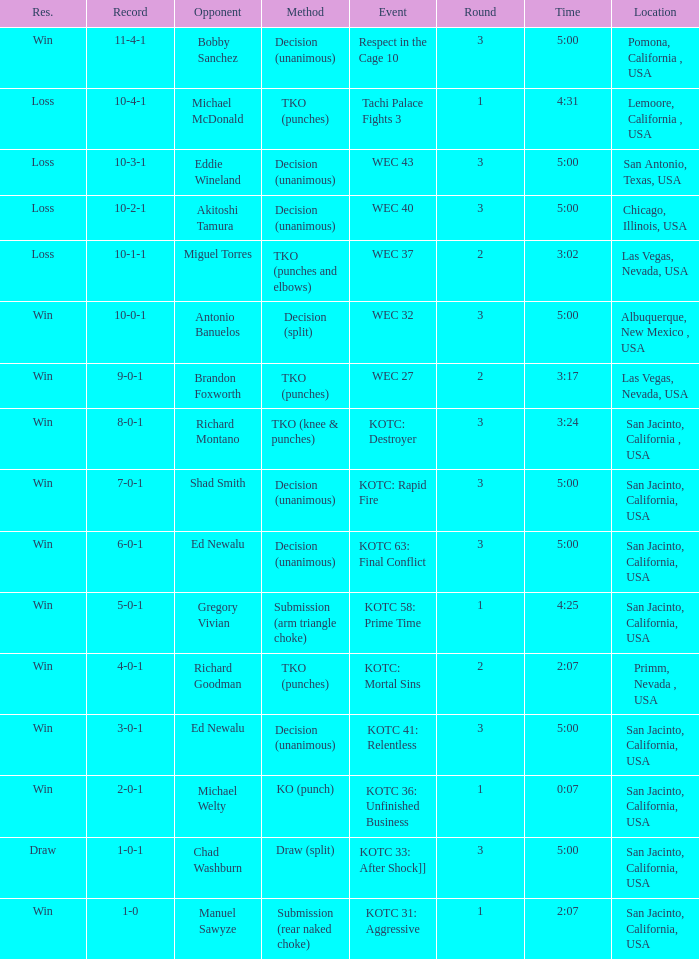What time did the even tachi palace fights 3 take place? 4:31. 